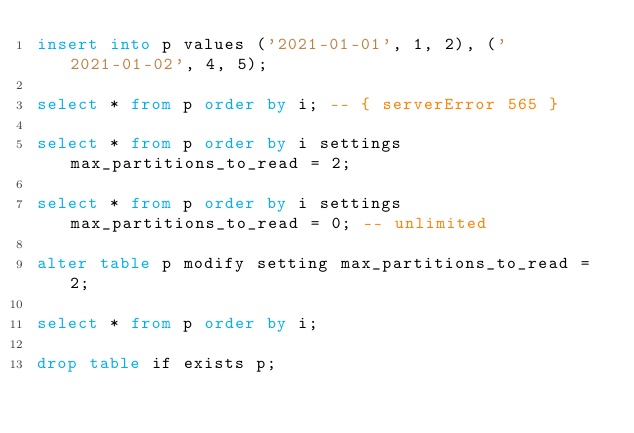Convert code to text. <code><loc_0><loc_0><loc_500><loc_500><_SQL_>insert into p values ('2021-01-01', 1, 2), ('2021-01-02', 4, 5);

select * from p order by i; -- { serverError 565 }

select * from p order by i settings max_partitions_to_read = 2;

select * from p order by i settings max_partitions_to_read = 0; -- unlimited

alter table p modify setting max_partitions_to_read = 2;

select * from p order by i;

drop table if exists p;
</code> 